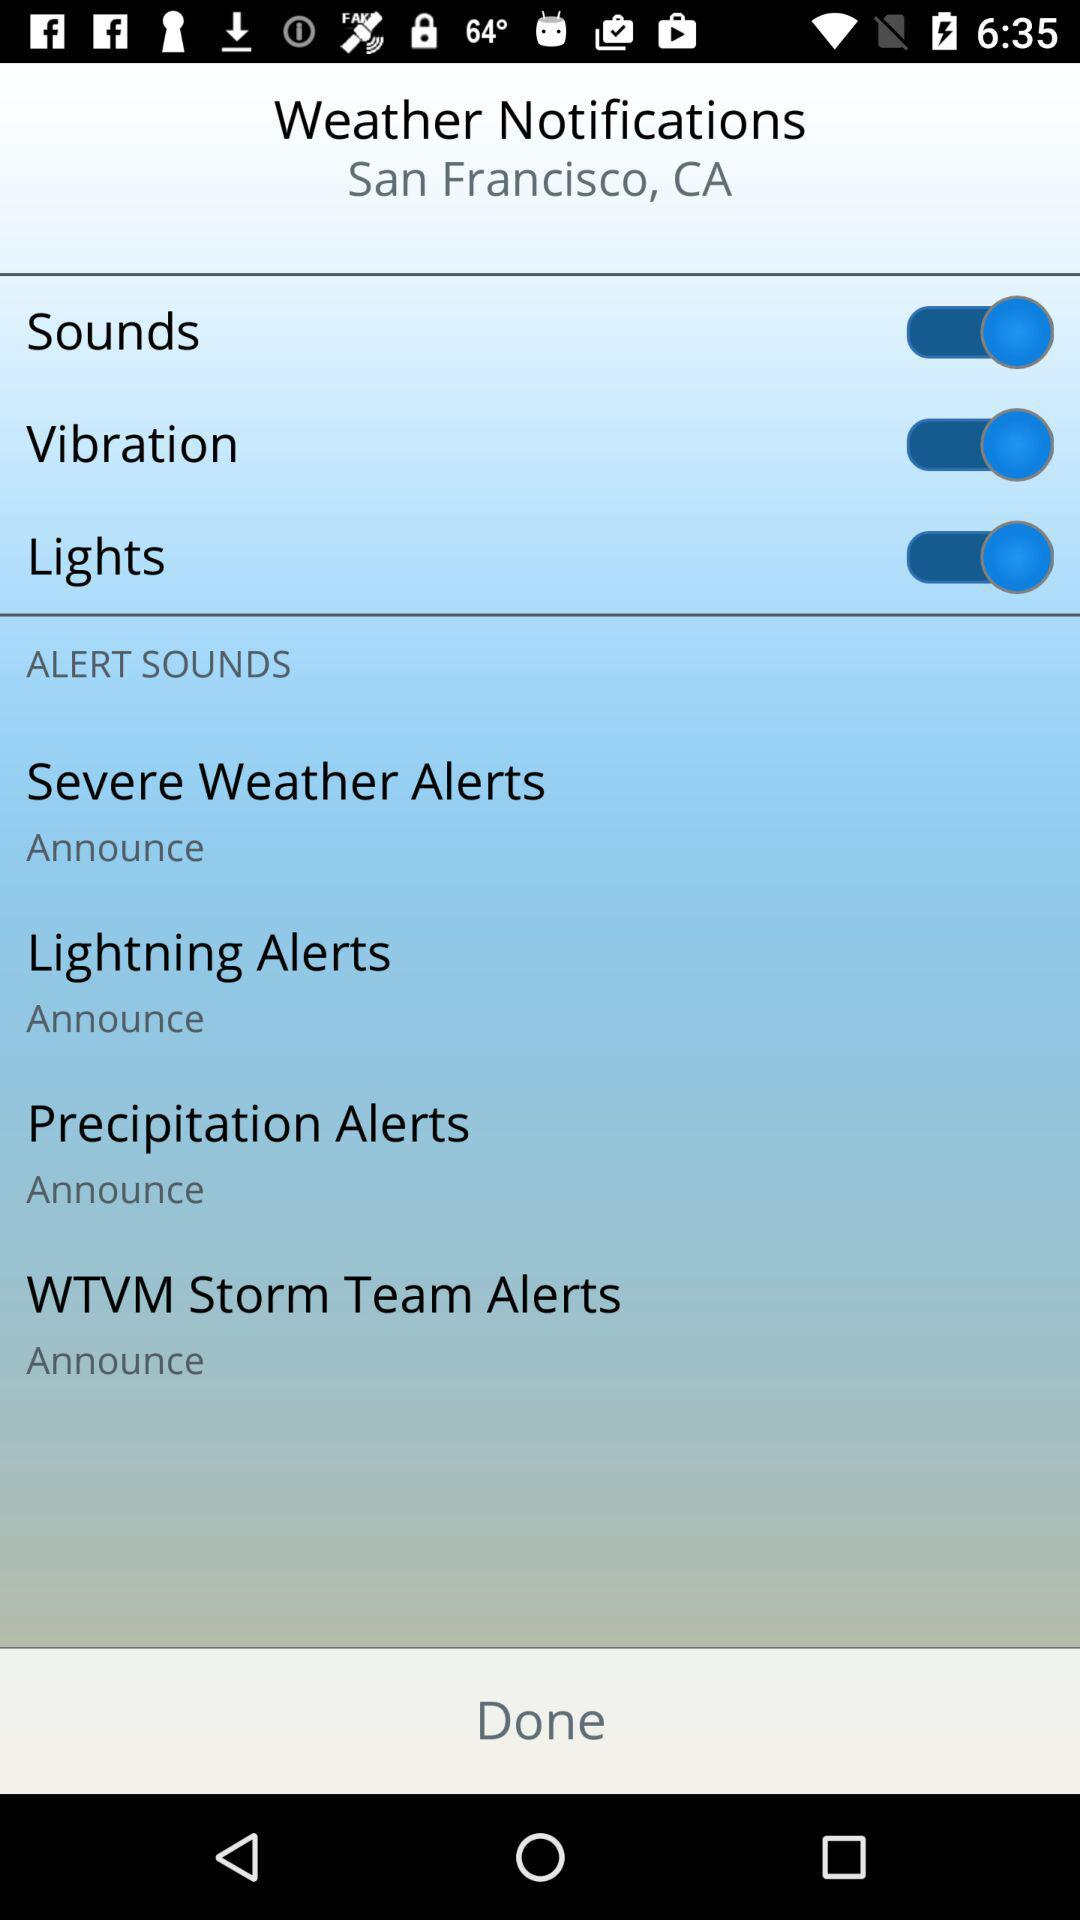What is the status of "Sounds"? The status is "on". 